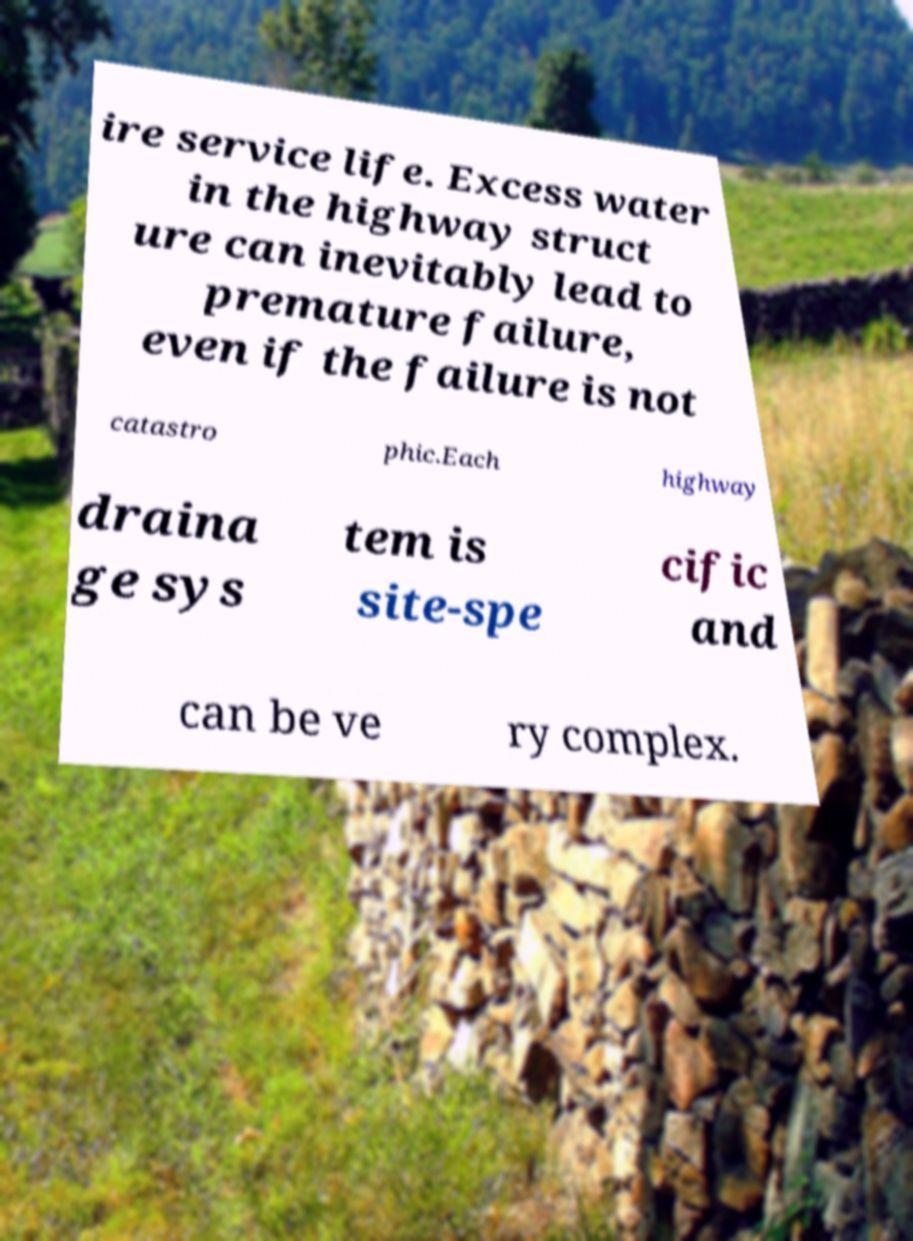There's text embedded in this image that I need extracted. Can you transcribe it verbatim? ire service life. Excess water in the highway struct ure can inevitably lead to premature failure, even if the failure is not catastro phic.Each highway draina ge sys tem is site-spe cific and can be ve ry complex. 